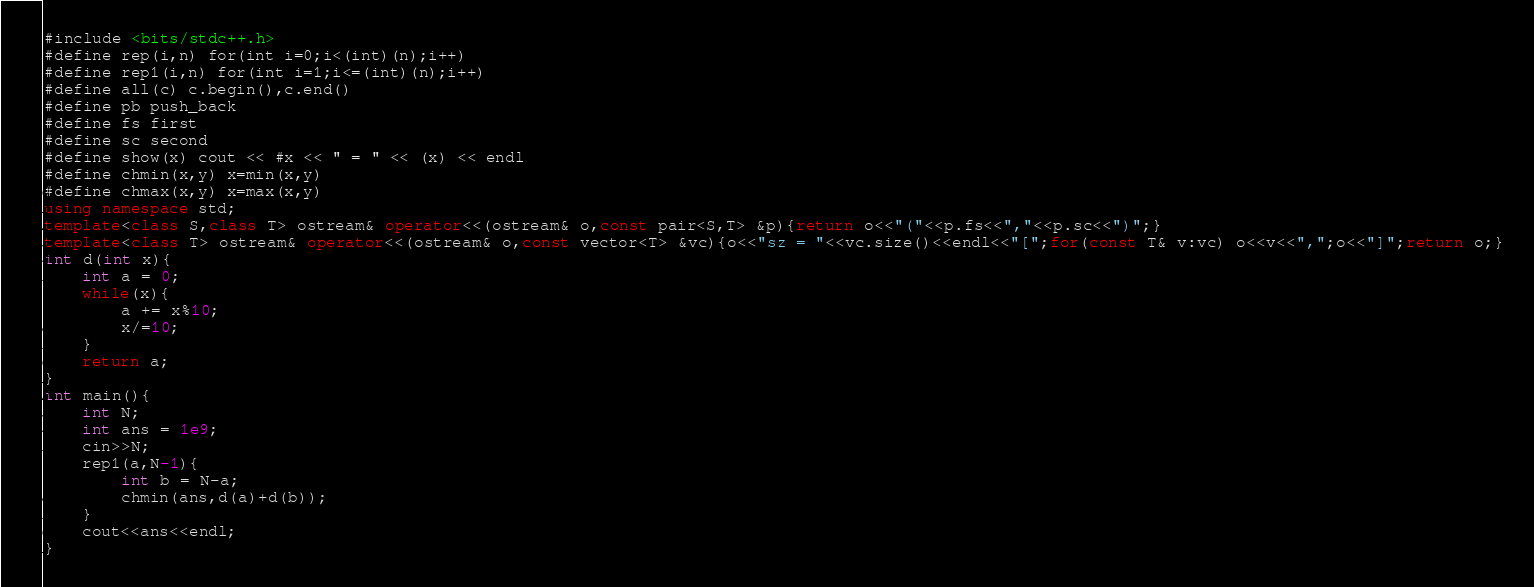<code> <loc_0><loc_0><loc_500><loc_500><_C++_>#include <bits/stdc++.h>
#define rep(i,n) for(int i=0;i<(int)(n);i++)
#define rep1(i,n) for(int i=1;i<=(int)(n);i++)
#define all(c) c.begin(),c.end()
#define pb push_back
#define fs first
#define sc second
#define show(x) cout << #x << " = " << (x) << endl
#define chmin(x,y) x=min(x,y)
#define chmax(x,y) x=max(x,y)
using namespace std;
template<class S,class T> ostream& operator<<(ostream& o,const pair<S,T> &p){return o<<"("<<p.fs<<","<<p.sc<<")";}
template<class T> ostream& operator<<(ostream& o,const vector<T> &vc){o<<"sz = "<<vc.size()<<endl<<"[";for(const T& v:vc) o<<v<<",";o<<"]";return o;}
int d(int x){
	int a = 0;
	while(x){
		a += x%10;
		x/=10;
	}
	return a;
}
int main(){
	int N;
	int ans = 1e9;
	cin>>N;
	rep1(a,N-1){
		int b = N-a;
		chmin(ans,d(a)+d(b));
	}
	cout<<ans<<endl;
}
</code> 